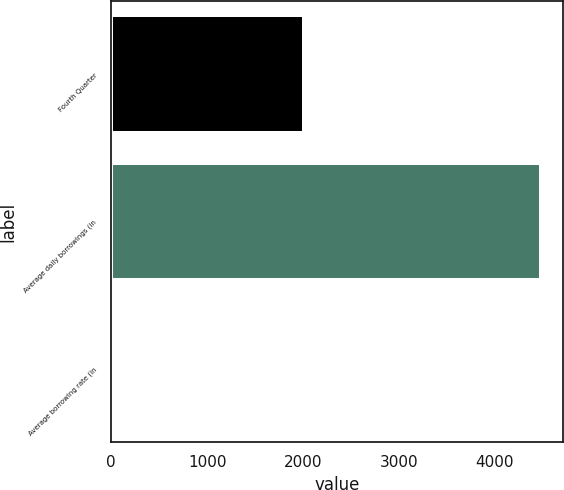Convert chart. <chart><loc_0><loc_0><loc_500><loc_500><bar_chart><fcel>Fourth Quarter<fcel>Average daily borrowings (in<fcel>Average borrowing rate (in<nl><fcel>2012<fcel>4484<fcel>7<nl></chart> 